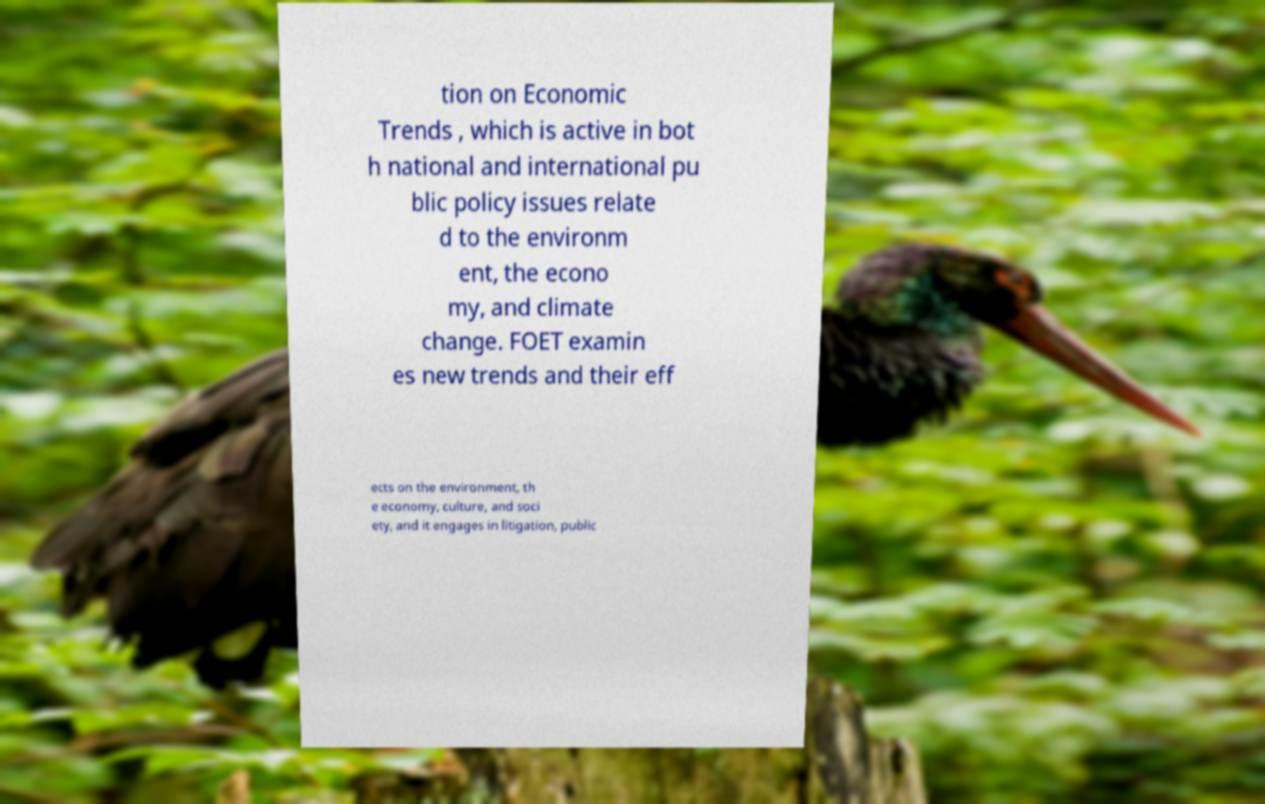What messages or text are displayed in this image? I need them in a readable, typed format. tion on Economic Trends , which is active in bot h national and international pu blic policy issues relate d to the environm ent, the econo my, and climate change. FOET examin es new trends and their eff ects on the environment, th e economy, culture, and soci ety, and it engages in litigation, public 